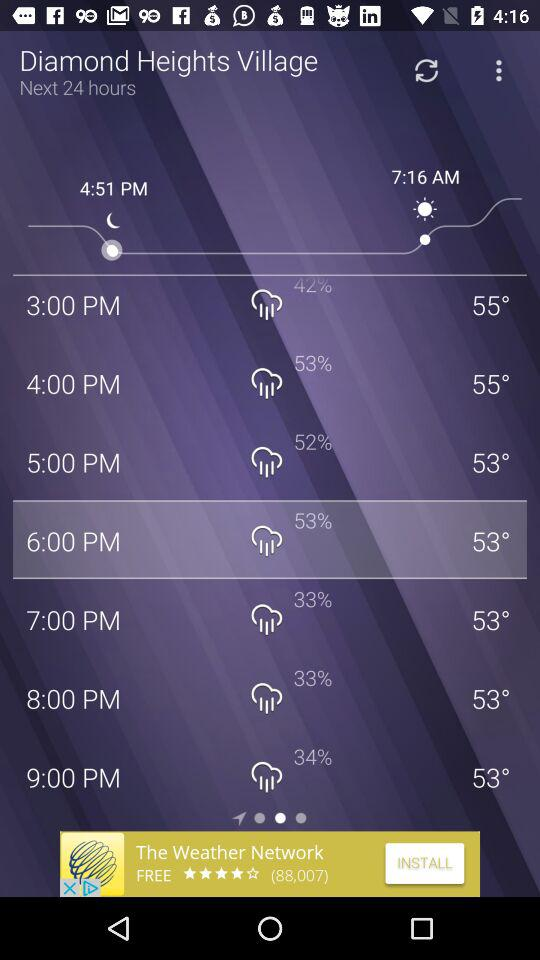For what duration of timing graph has given?
When the provided information is insufficient, respond with <no answer>. <no answer> 